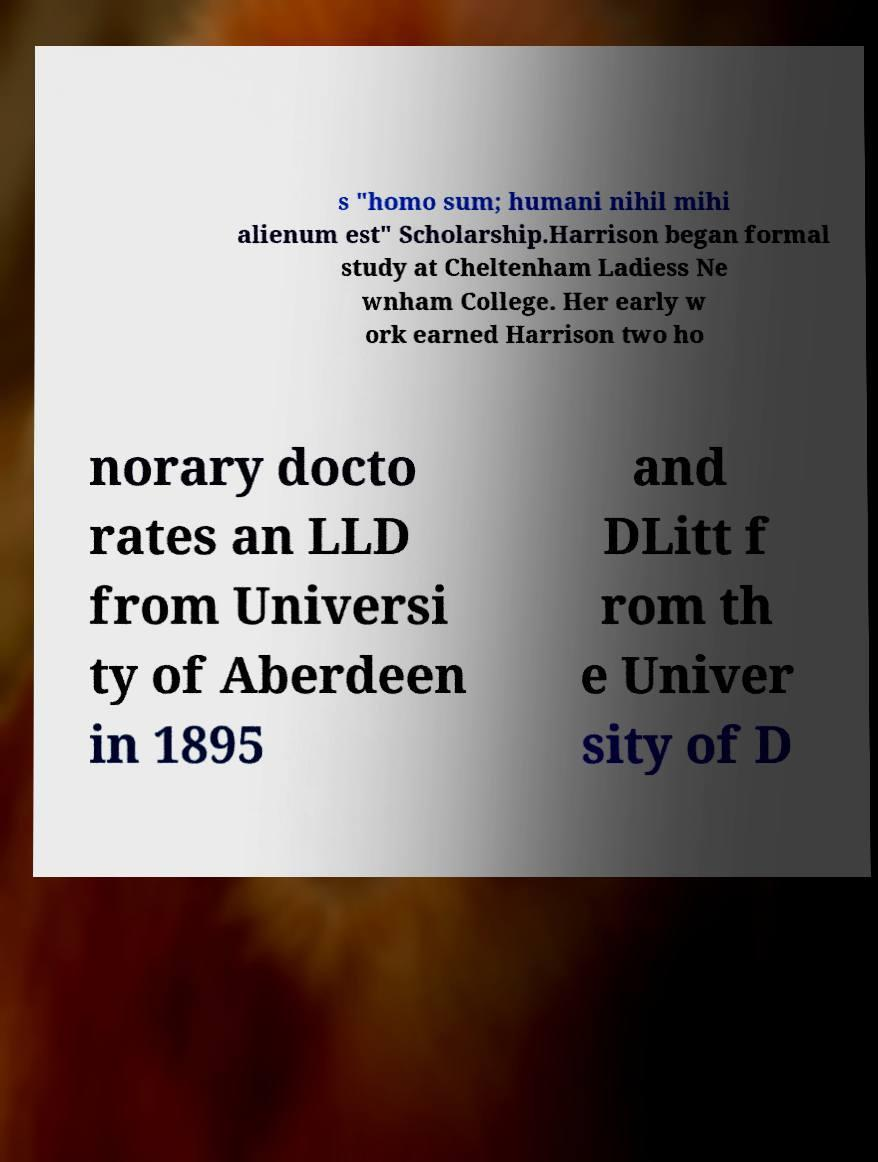Could you extract and type out the text from this image? s "homo sum; humani nihil mihi alienum est" Scholarship.Harrison began formal study at Cheltenham Ladiess Ne wnham College. Her early w ork earned Harrison two ho norary docto rates an LLD from Universi ty of Aberdeen in 1895 and DLitt f rom th e Univer sity of D 